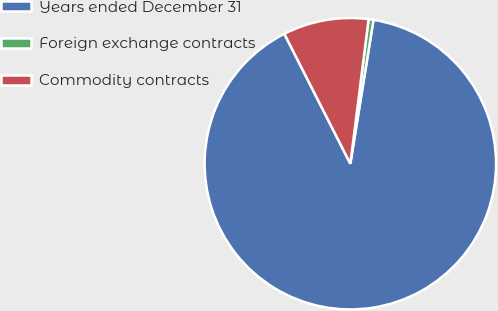<chart> <loc_0><loc_0><loc_500><loc_500><pie_chart><fcel>Years ended December 31<fcel>Foreign exchange contracts<fcel>Commodity contracts<nl><fcel>89.98%<fcel>0.54%<fcel>9.48%<nl></chart> 